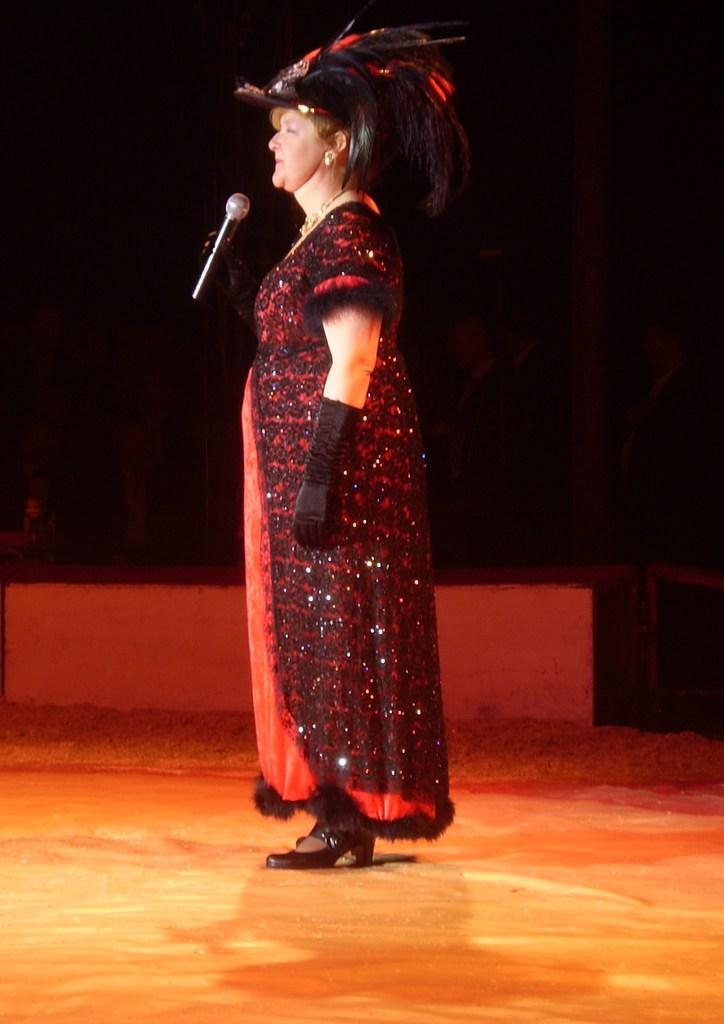Who is the main subject in the image? There is a woman in the image. What is the woman holding in the image? The woman is holding a microphone. Can you describe the background of the image? The background of the image is dark. What type of hole can be seen in the image? There is no hole present in the image. Is the woman's car visible in the image? There is no car present in the image. 